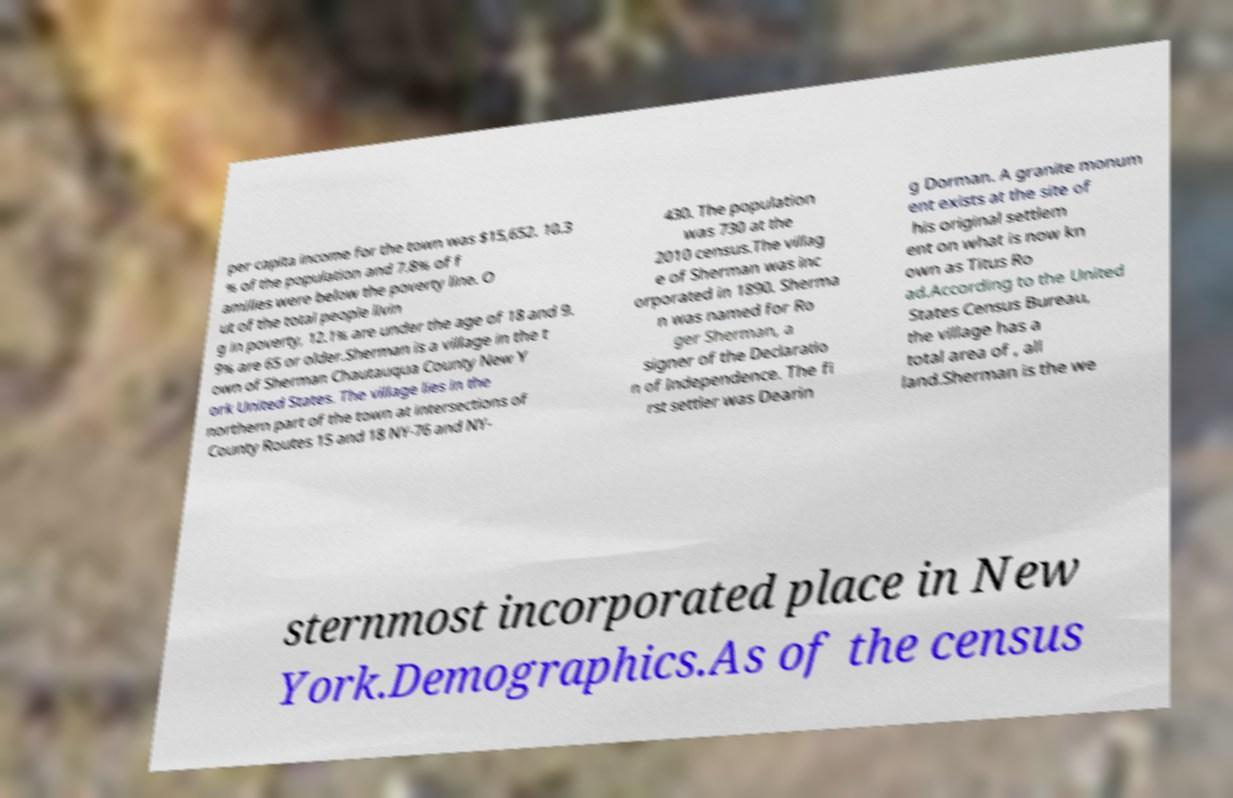There's text embedded in this image that I need extracted. Can you transcribe it verbatim? per capita income for the town was $15,652. 10.3 % of the population and 7.8% of f amilies were below the poverty line. O ut of the total people livin g in poverty, 12.1% are under the age of 18 and 9. 9% are 65 or older.Sherman is a village in the t own of Sherman Chautauqua County New Y ork United States. The village lies in the northern part of the town at intersections of County Routes 15 and 18 NY-76 and NY- 430. The population was 730 at the 2010 census.The villag e of Sherman was inc orporated in 1890. Sherma n was named for Ro ger Sherman, a signer of the Declaratio n of Independence. The fi rst settler was Dearin g Dorman. A granite monum ent exists at the site of his original settlem ent on what is now kn own as Titus Ro ad.According to the United States Census Bureau, the village has a total area of , all land.Sherman is the we sternmost incorporated place in New York.Demographics.As of the census 